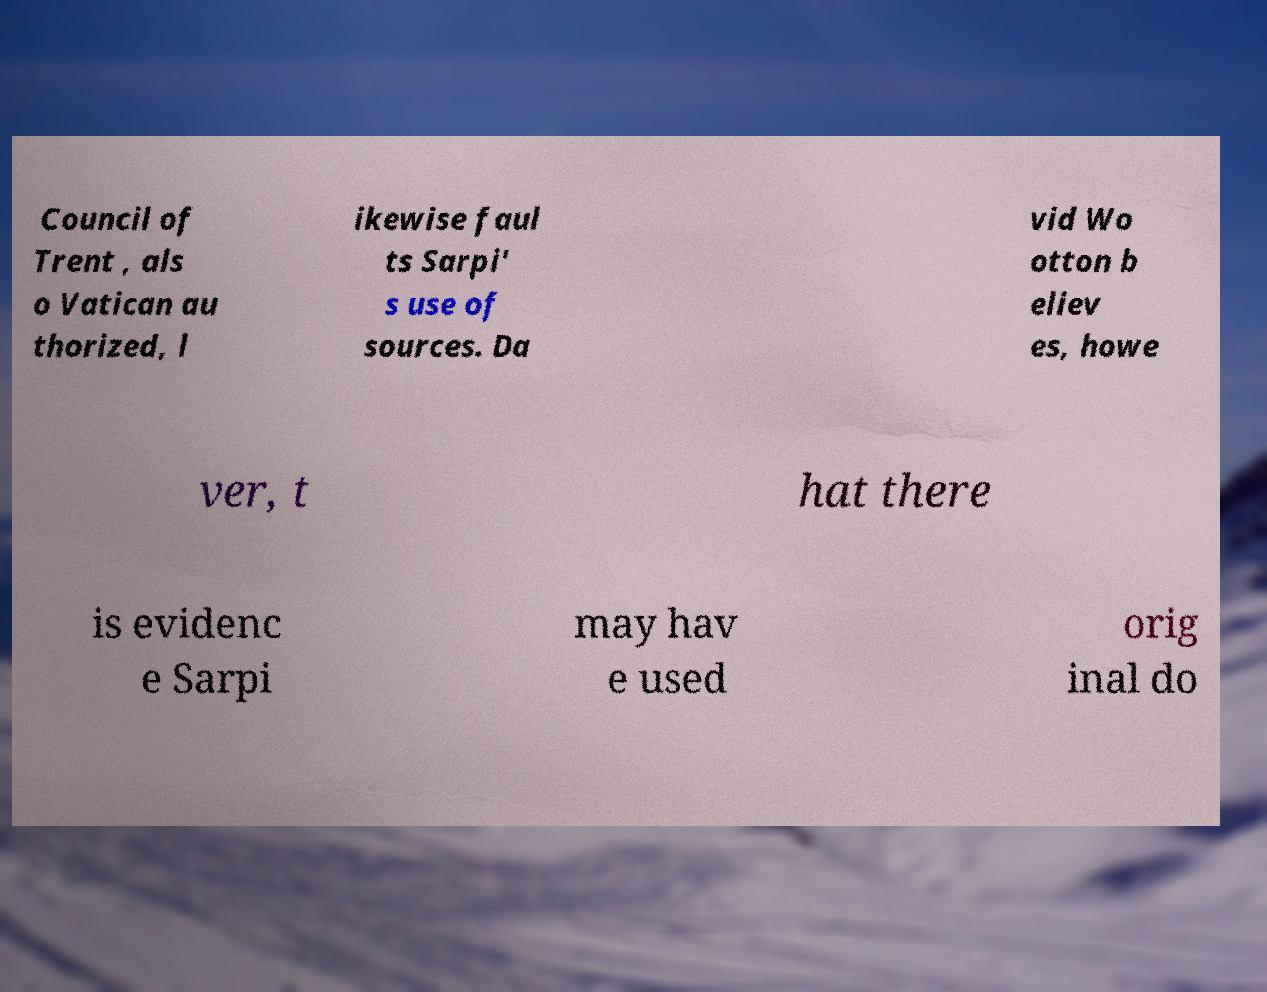What messages or text are displayed in this image? I need them in a readable, typed format. Council of Trent , als o Vatican au thorized, l ikewise faul ts Sarpi' s use of sources. Da vid Wo otton b eliev es, howe ver, t hat there is evidenc e Sarpi may hav e used orig inal do 